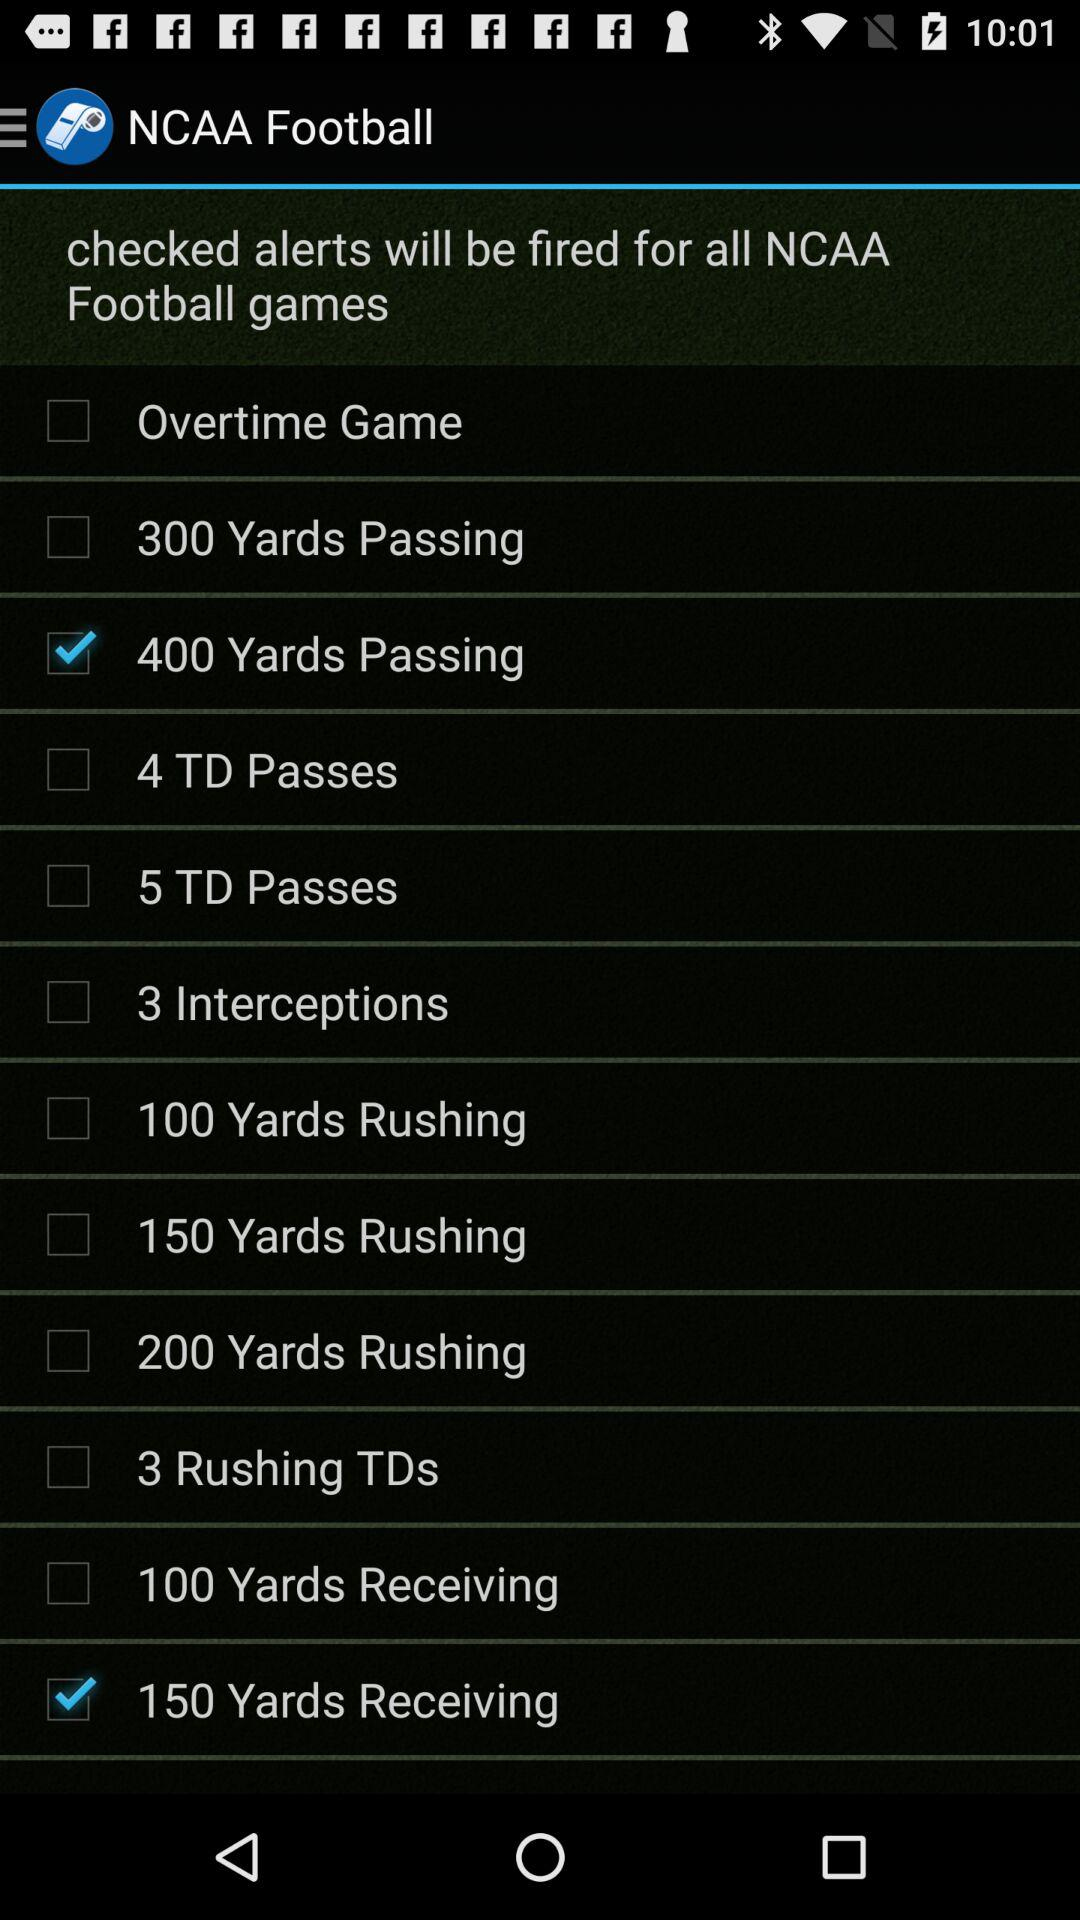What is the status of "4 TD Passes"? The status is "off". 